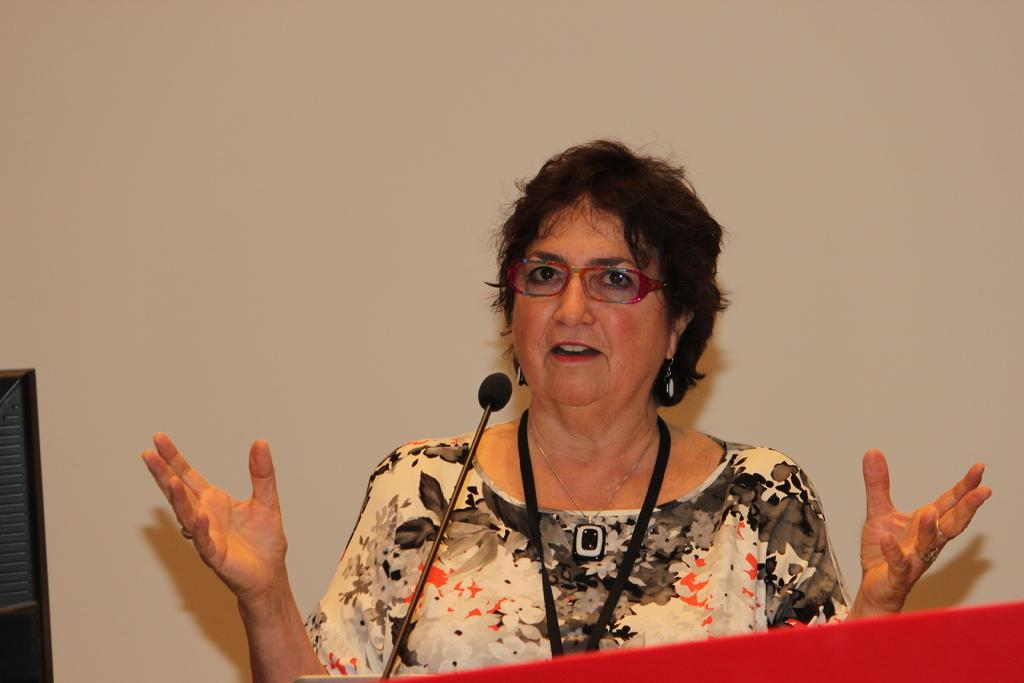Who is the main subject in the image? There is a woman in the image. What is the woman doing in the image? The woman is standing at a podium. What object is attached to the podium? A microphone is attached to the podium. What is the woman's brother writing on the podium in the image? There is no brother or writing present in the image. The woman is standing at a podium with a microphone attached to it. 